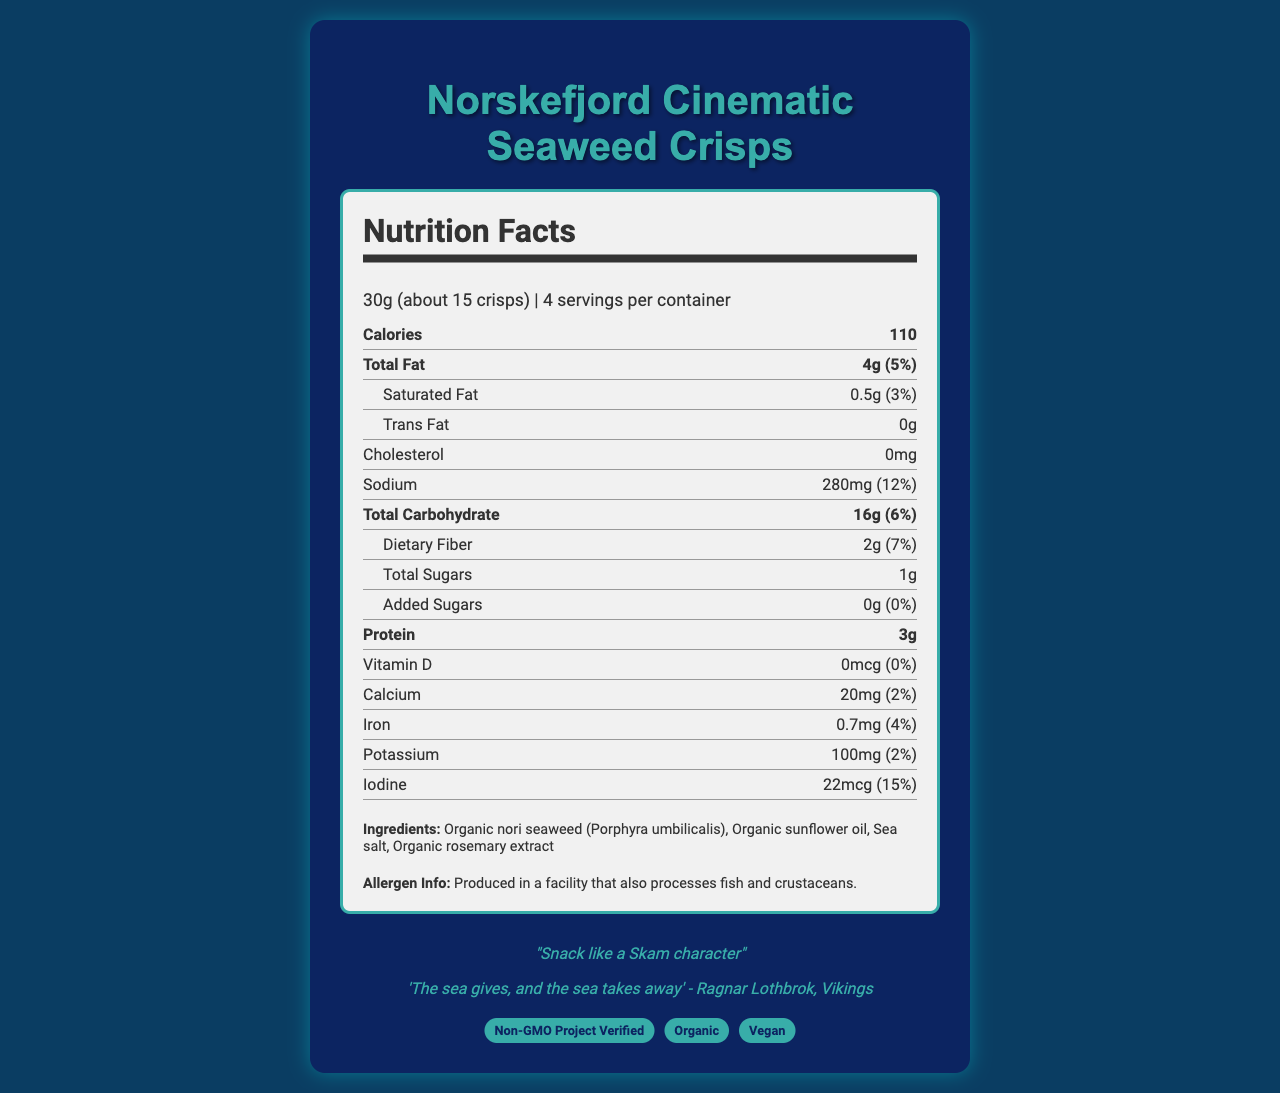What is the product name? The product name is clearly stated at the top of the document.
Answer: Norskefjord Cinematic Seaweed Crisps How many calories are in one serving? The calories per serving are listed as 110 in the nutrition label section.
Answer: 110 How much protein is in one serving? The amount of protein per serving is listed as 3g in the nutrition facts.
Answer: 3g What is the daily value percentage of iodine in one serving? The daily value percentage of iodine is specified as 15% in the nutrition facts section.
Answer: 15% What are the main ingredients in the Norskefjord Cinematic Seaweed Crisps? The ingredients are listed in the document under the "Ingredients" section.
Answer: Organic nori seaweed, Organic sunflower oil, Sea salt, Organic rosemary extract What is the serving size? The serving size is stated as 30g (about 15 crisps) in the document.
Answer: 30g (about 15 crisps) Does the product contain any added sugars? The amount of added sugars is listed as 0g with a daily value of 0%.
Answer: No Which certifications does this product have? A. Non-GMO Project Verified B. Organic C. Vegan D. All of the above The certifications section mentions that the product is Non-GMO Project Verified, Organic, and Vegan.
Answer: D. All of the above What is the total fat content in one serving? A. 2g B. 4g C. 6g D. 8g The total fat content per serving is listed as 4g in the nutrition facts.
Answer: B. 4g What is the color scheme mentioned for the packaging design? The color scheme is stated as deep blue and emerald green in the packaging features section.
Answer: Deep blue and emerald green Does the product contain cholesterol? The amount of cholesterol is noted as 0mg in the nutrition facts.
Answer: No Summarize the main ideas of the document. The document primarily presents a comprehensive overview of the nutritional content, ingredients, and relevant details of Norskefjord Cinematic Seaweed Crisps, including design and thematic elements connected to Norwegian drama, along with sustainability and certification information.
Answer: The document provides detailed nutrition facts and ingredient information for Norskefjord Cinematic Seaweed Crisps, a snack inspired by Norwegian drama. It includes certifications, packaging design details, and a connection to Norwegian drama with a tagline and quote. Additionally, it mentions allergen information and sustainability practices. What is the flavor inspiration for the product? The flavor inspiration is stated as being influenced by the coastal scenes in the Norwegian drama 'Occupied (Okkupert)'.
Answer: Inspired by the coastal scenes in Occupied (Okkupert) What packaging imagery is used on the product? The packaging features include imagery of a silhouette of a Viking longship.
Answer: Silhouette of a Viking longship What is the calcium content in one serving? The calcium content per serving is listed as 20mg in the nutrition facts.
Answer: 20mg What is the product's tagline? The tagline of the product is mentioned as "Snack like a Skam character" in the Norwegian drama connection section.
Answer: Snack like a Skam character Who is quoted in the packaging quote? The quote on the packaging is attributed to Ragnar Lothbrok from the show "Vikings".
Answer: Ragnar Lothbrok Is the product produced in a facility that processes fish? The allergen information specifies that the product is produced in a facility that also processes fish and crustaceans.
Answer: Yes Where is the seaweed sourced from? The seaweed is sourced from sustainable seaweed farms in the Sognefjord as stated in the sustainability info section.
Answer: Sognefjord How many servings are there per container? The document specifies that there are 4 servings per container.
Answer: 4 Can the total revenue from selling this product be determined from the document? The document does not provide any sales or revenue information.
Answer: Cannot be determined 